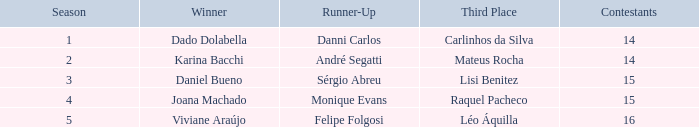Who was the winner when Mateus Rocha finished in 3rd place?  Karina Bacchi. 